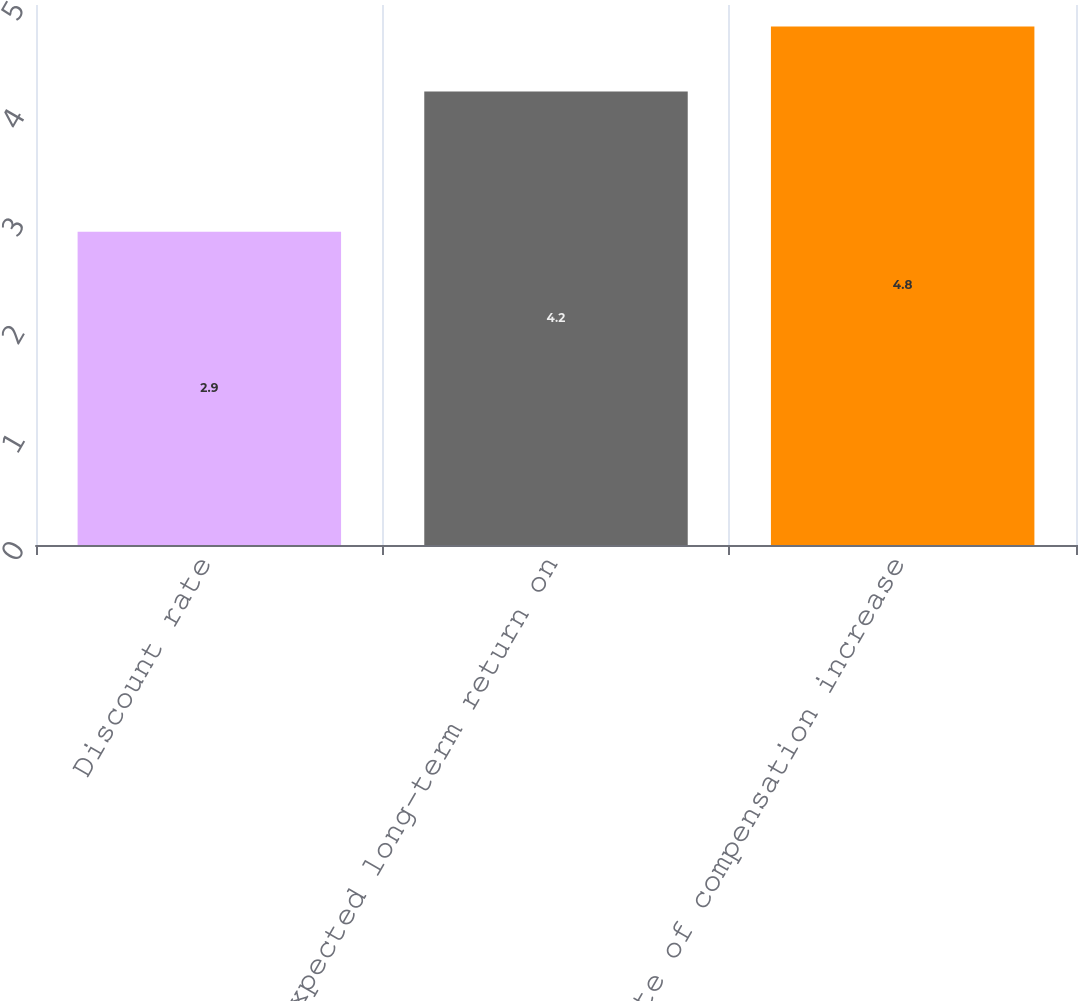Convert chart. <chart><loc_0><loc_0><loc_500><loc_500><bar_chart><fcel>Discount rate<fcel>Expected long-term return on<fcel>Rate of compensation increase<nl><fcel>2.9<fcel>4.2<fcel>4.8<nl></chart> 